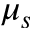<formula> <loc_0><loc_0><loc_500><loc_500>\mu _ { s }</formula> 